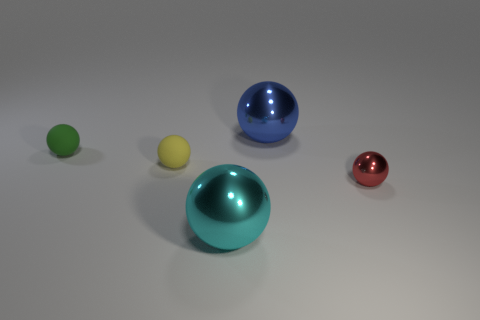There is a metal object behind the tiny shiny object; does it have the same size as the thing that is to the right of the blue shiny sphere?
Keep it short and to the point. No. There is a yellow object that is the same size as the green rubber sphere; what is its material?
Your answer should be compact. Rubber. What number of tiny cyan rubber cubes are there?
Provide a succinct answer. 0. What is the size of the object that is right of the big blue thing?
Offer a terse response. Small. Are there the same number of small things behind the small green rubber thing and purple objects?
Provide a succinct answer. Yes. Is there a green rubber object that has the same shape as the red shiny object?
Your answer should be compact. Yes. What is the shape of the thing that is left of the red metallic ball and in front of the yellow ball?
Provide a short and direct response. Sphere. Are the green ball and the small yellow sphere to the left of the tiny red metallic sphere made of the same material?
Keep it short and to the point. Yes. There is a tiny red shiny thing; are there any large metal objects in front of it?
Provide a short and direct response. Yes. How many objects are tiny blue shiny spheres or objects behind the large cyan metal object?
Offer a terse response. 4. 